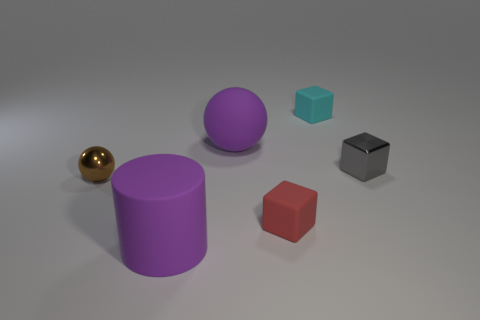There is a small gray shiny cube; how many tiny brown shiny objects are behind it? 0 